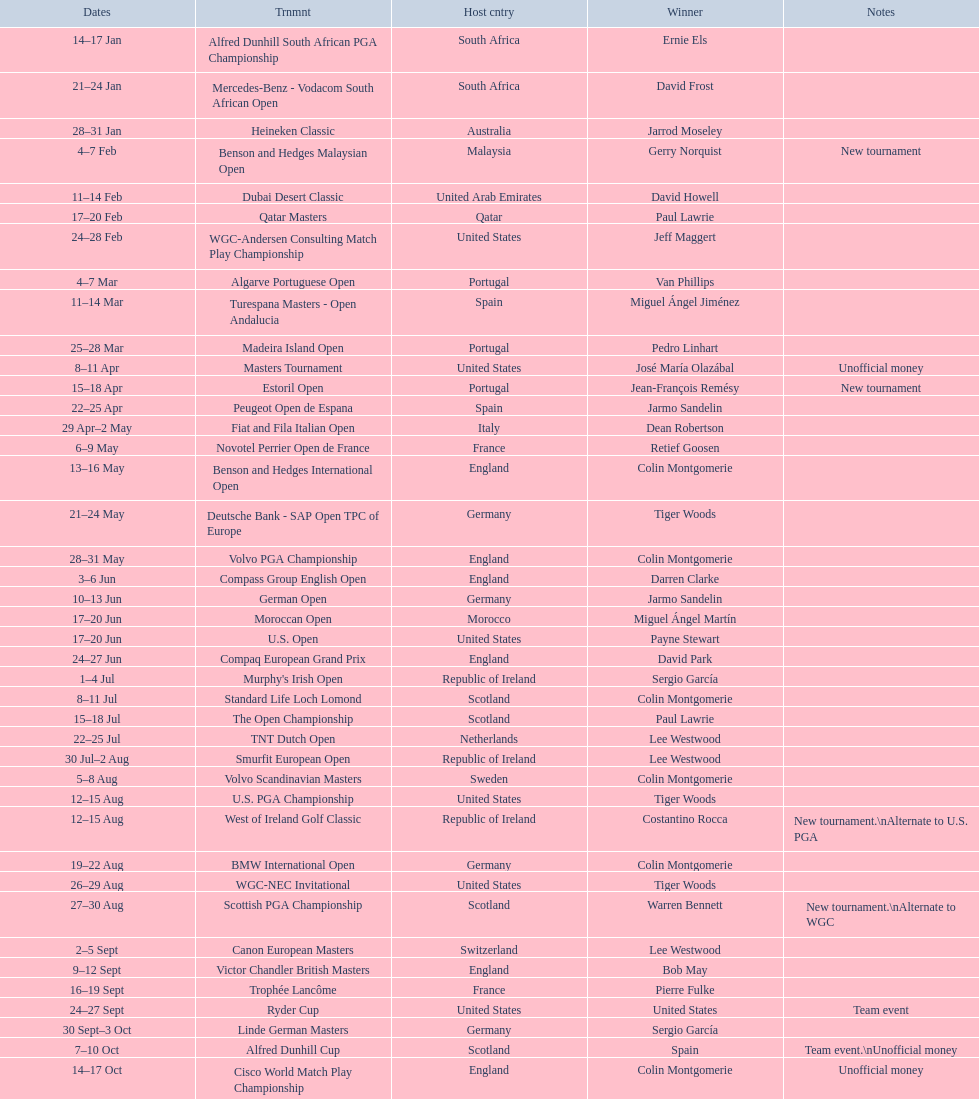What was the country listed the first time there was a new tournament? Malaysia. 